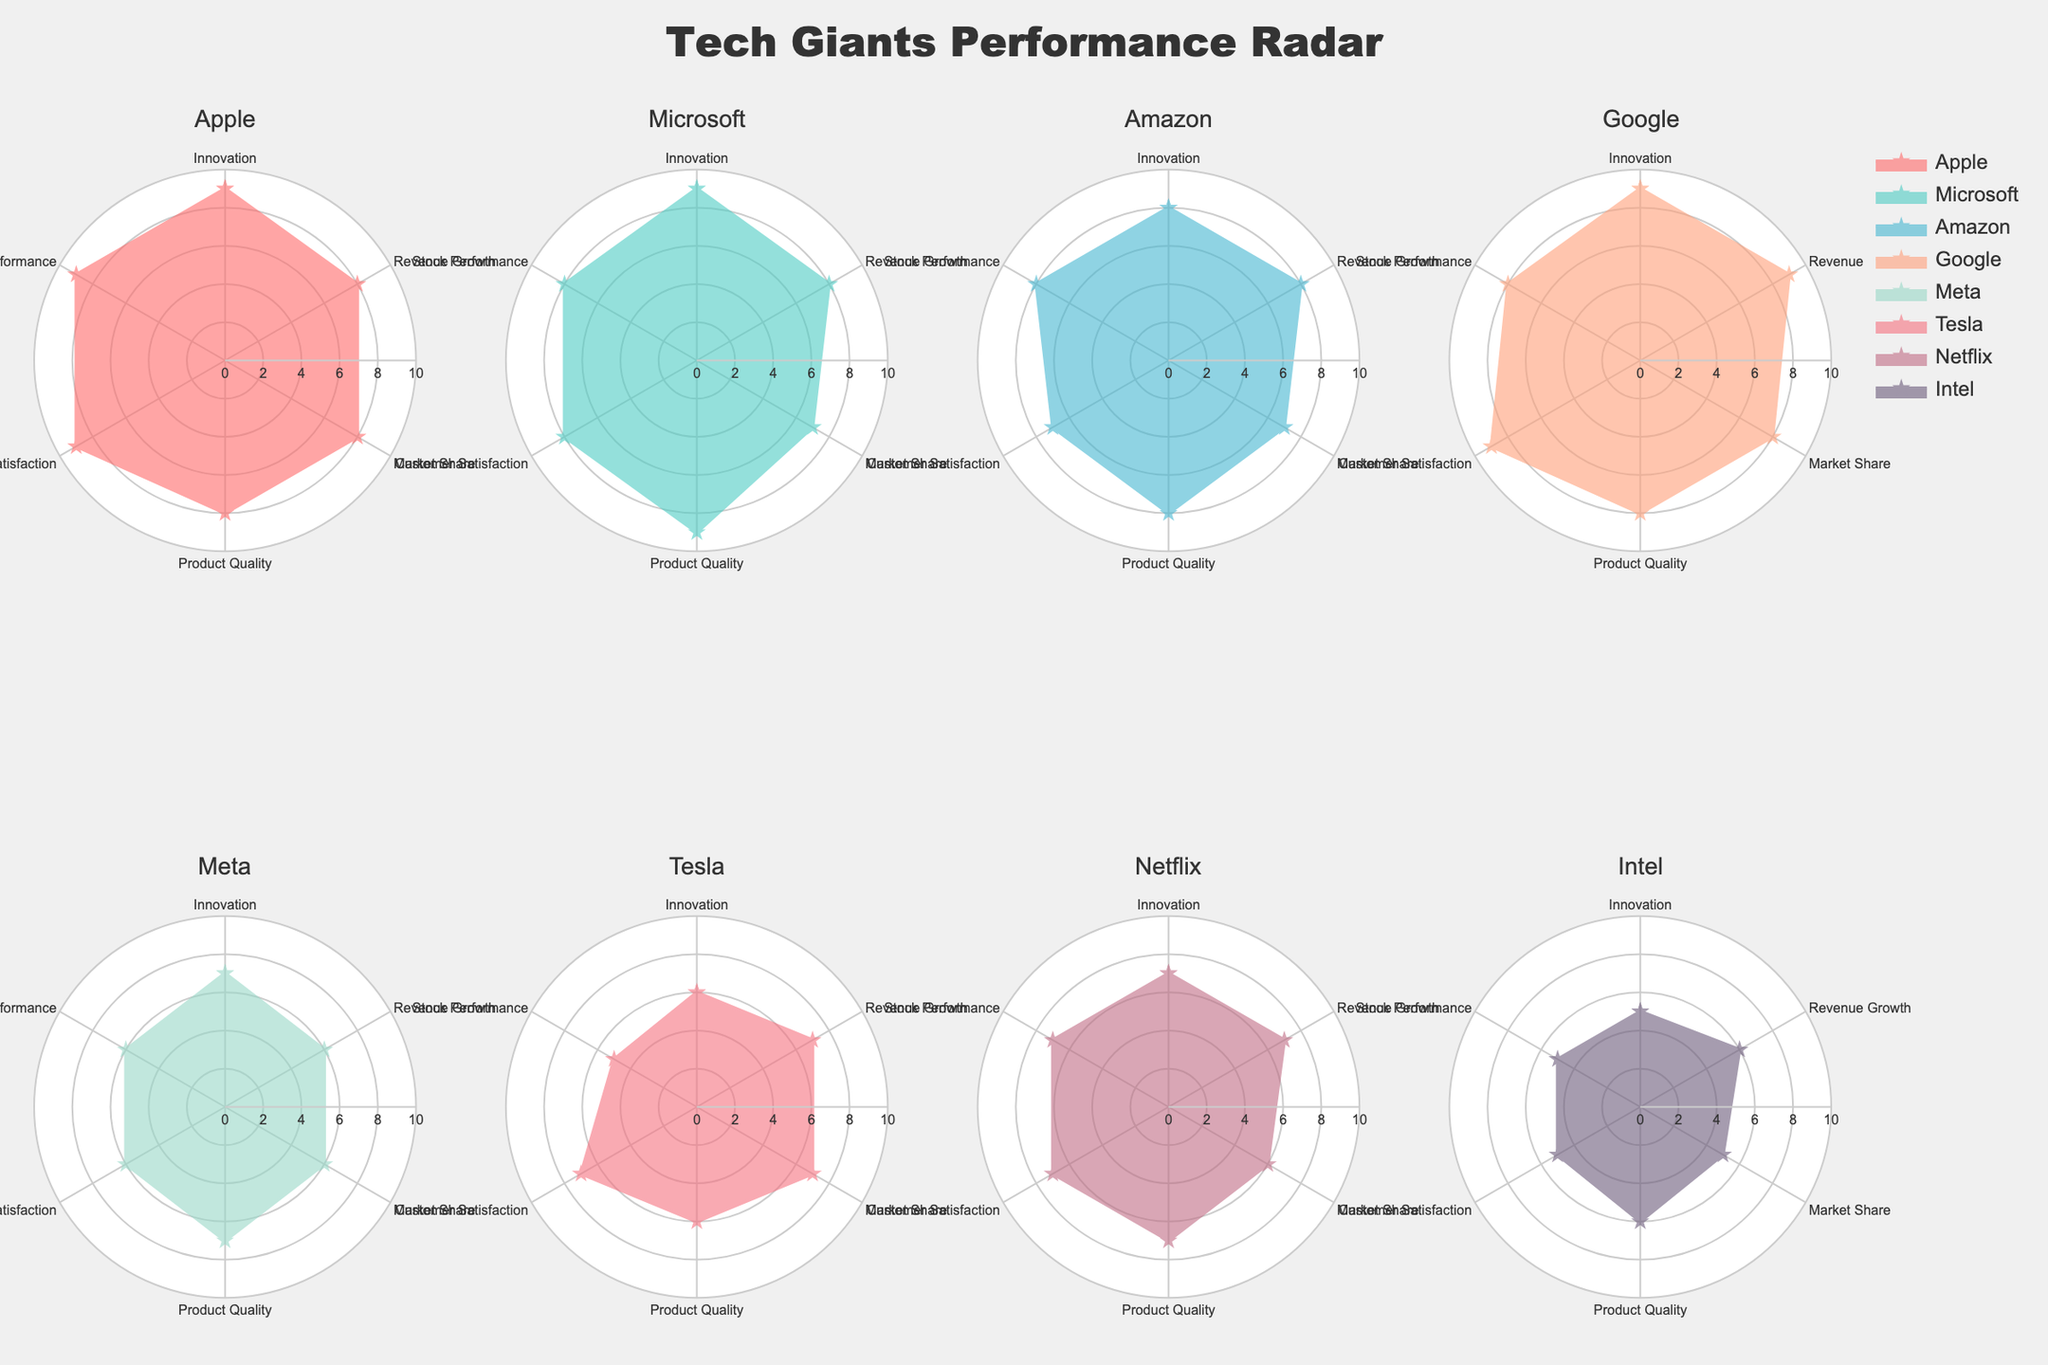What is the title of the figure? The title of the figure is usually located at the top. In this case, it reads "Tech Giants Performance Radar".
Answer: Tech Giants Performance Radar Which company has the highest value for Customer Satisfaction? By looking at the subplot for each company, the highest Customer Satisfaction value is for Apple, with a score of 9.
Answer: Apple How does Tesla perform in terms of Stock Performance compared to Apple? Tesla's Stock Performance is represented by the radial value. For Tesla, that value is 5, while for Apple, it's 9. Therefore, Tesla's Stock Performance is lower than Apple's.
Answer: Tesla's Stock Performance is lower than Apple's What is the range of Market Share values across all companies? To find the range, identify the minimum and maximum values of Market Share from the subplots. The values range from 5 for Intel to 8 for Google and Apple. So, the range is 8 - 5 = 3.
Answer: 3 Which company has the lowest Innovation score, and what is that score? By reviewing each subplot, Intel has the lowest Innovation score, with a value of 5.
Answer: Intel, score 5 Compare Netflix and Meta in terms of Revenue Growth and Product Quality. Netflix has a Revenue Growth of 7 and Product Quality of 7, while Meta has a Revenue Growth of 6 and Product Quality of 7. So, Netflix has higher Revenue Growth, and their Product Quality is the same.
Answer: Netflix has higher Revenue Growth, same Product Quality What is the total Stock Performance value if you sum up the values of Google, Microsoft, and Amazon? By checking each company's subplot, Google has a Stock Performance of 8, Microsoft has 8, and Amazon also has 8. Summing these gives 8 + 8 + 8 = 24.
Answer: 24 Which companies have a Market Share value of 7? By inspecting each subplot, the companies with a Market Share value of 7 are Microsoft, Amazon, and Tesla.
Answer: Microsoft, Amazon, Tesla What is the average Product Quality score across all companies? Sum the Product Quality scores: 8 (Apple) + 9 (Microsoft) + 8 (Amazon) + 8 (Google) + 7 (Meta) + 6 (Tesla) + 7 (Netflix) + 6 (Intel) = 59. There are 8 companies, so the average is 59 / 8 = 7.375.
Answer: 7.375 